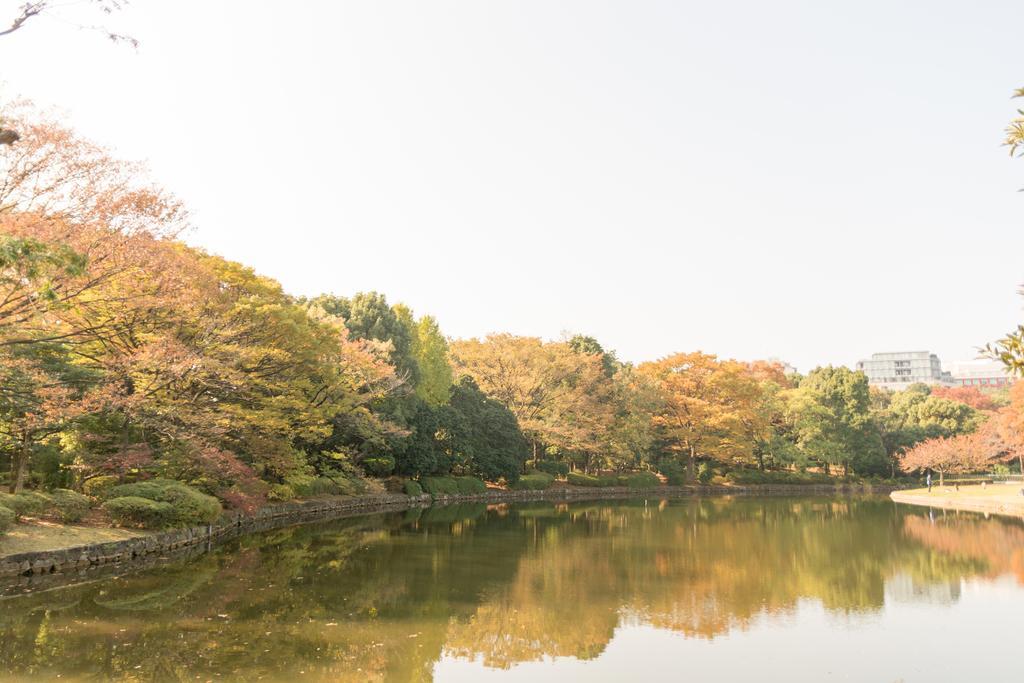Please provide a concise description of this image. In this picture I can see there is a lake and there are trees, plants and in the backdrop I can see there is a building and the sky is clear. 